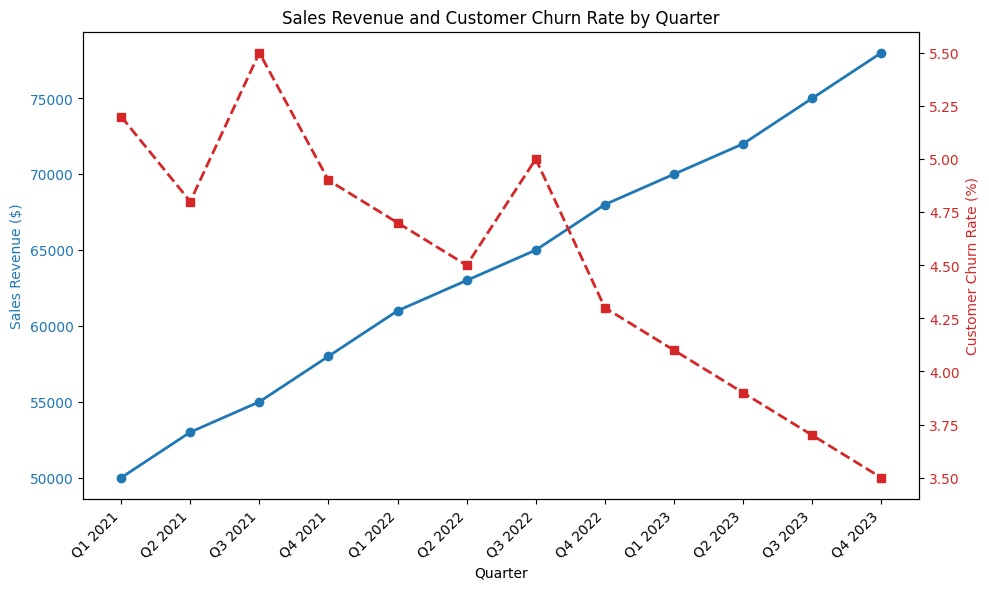What is the Customer Churn Rate for Q2 2022? To find the Customer Churn Rate for Q2 2022, look at the red dashed line corresponding to Q2 2022. The Y-axis on the right-hand side shows the rate. For Q2 2022, it is marked as 4.5%.
Answer: 4.5% How does the Sales Revenue in Q4 2023 compare to Q4 2021? To compare the Sales Revenue between Q4 2023 and Q4 2021, look at the blue line for both quarters. Q4 2021 has a Sales Revenue of $58,000, and Q4 2023 has a Sales Revenue of $78,000.
Answer: Q4 2023 has a higher Sales Revenue by $20,000 compared to Q4 2021 What's the difference in Customer Churn Rate between Q1 2021 and Q4 2023? To find the difference, locate the Customer Churn Rates for both Q1 2021 and Q4 2023 from the red dashed line. Q1 2021 has a rate of 5.2%, and Q4 2023 has a rate of 3.5%. The difference is 5.2% - 3.5%.
Answer: 1.7% Identify the quarter with the highest Customer Churn Rate and provide its value. To find the quarter with the highest Customer Churn Rate, observe the peaks of the red dashed line. Q3 2021 has the highest value at 5.5%.
Answer: Q3 2021, 5.5% What is the average Sales Revenue across all quarters shown? To compute the average Sales Revenue, add up all the quarterly Sales Revenues and divide by the number of quarters. The sum is ($50,000 + $53,000 + $55,000 + $58,000 + $61,000 + $63,000 + $65,000 + $68,000 + $70,000 + $72,000 + $75,000 + $78,000) which equals $768,000. There are 12 quarters. So, the average is $768,000 / 12.
Answer: $64,000 Does there appear to be a correlation between Sales Revenue and Customer Churn Rate? Look at the general trend of both lines. When Sales Revenue increases, Customer Churn Rate generally decreases, suggesting a negative correlation.
Answer: Yes, negative correlation During which quarter did the Sales Revenue first exceed $60,000? To find the first quarter where Sales Revenue exceeded $60,000, examine the blue line. Q1 2022 shows Sales Revenue of $61,000, which is the first instance it exceeds $60,000.
Answer: Q1 2022 Considering Q1 2021 and Q1 2023, how much did the Sales Revenue increase? To determine the increase, subtract the Sales Revenue of Q1 2021 from Q1 2023. Q1 2021 has $50,000 and Q1 2023 has $70,000. The increase is $70,000 - $50,000.
Answer: $20,000 How did the Customer Churn Rate change from Q1 2021 to Q2 2021? To identify the change, compare the Customer Churn Rates indicated by the red dashed line. Q1 2021 has a rate of 5.2%, and Q2 2021 has a rate of 4.8%. Therefore, the change is 5.2% - 4.8%.
Answer: -0.4% Is there any quarter where both Sales Revenue and Customer Churn Rate increased simultaneously compared to the previous quarter? Examine the blue and red lines together. In Q3 2021, the Sales Revenue increased to $55,000 (from $53,000 in Q2 2021) and the Customer Churn Rate also increased to 5.5% (from 4.8% in Q2 2021).
Answer: Yes, Q3 2021 